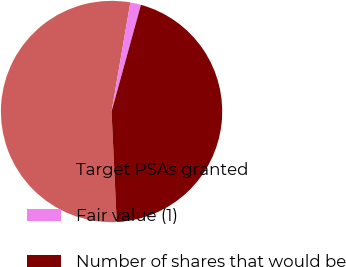<chart> <loc_0><loc_0><loc_500><loc_500><pie_chart><fcel>Target PSAs granted<fcel>Fair value (1)<fcel>Number of shares that would be<nl><fcel>53.46%<fcel>1.56%<fcel>44.98%<nl></chart> 